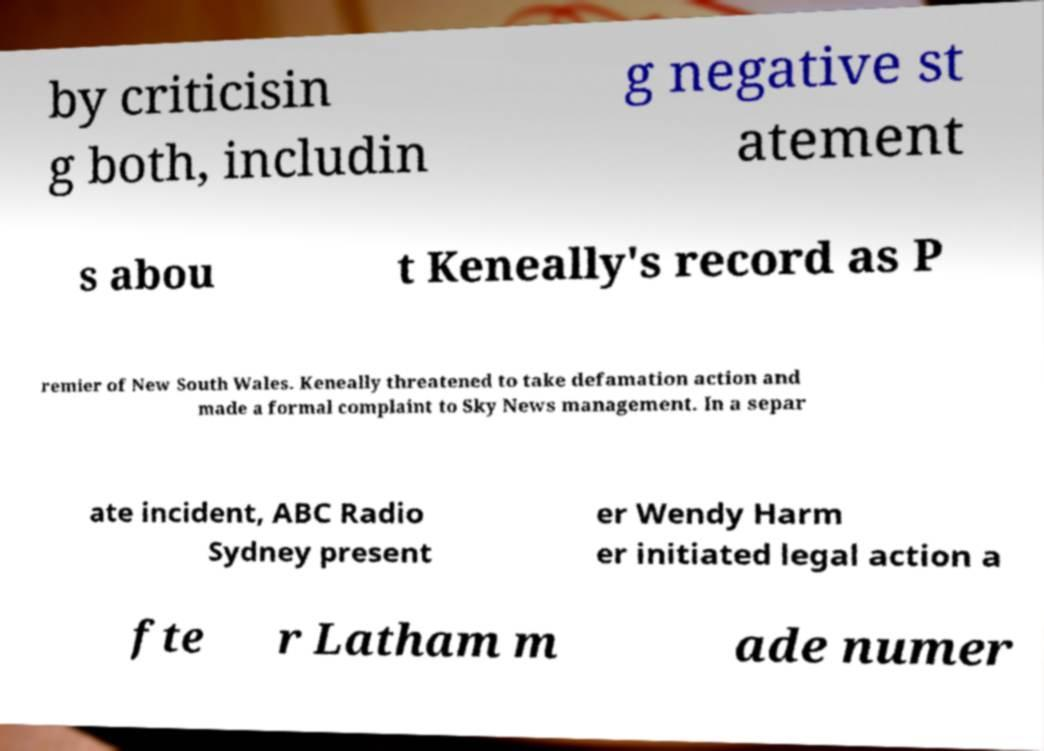Please read and relay the text visible in this image. What does it say? by criticisin g both, includin g negative st atement s abou t Keneally's record as P remier of New South Wales. Keneally threatened to take defamation action and made a formal complaint to Sky News management. In a separ ate incident, ABC Radio Sydney present er Wendy Harm er initiated legal action a fte r Latham m ade numer 